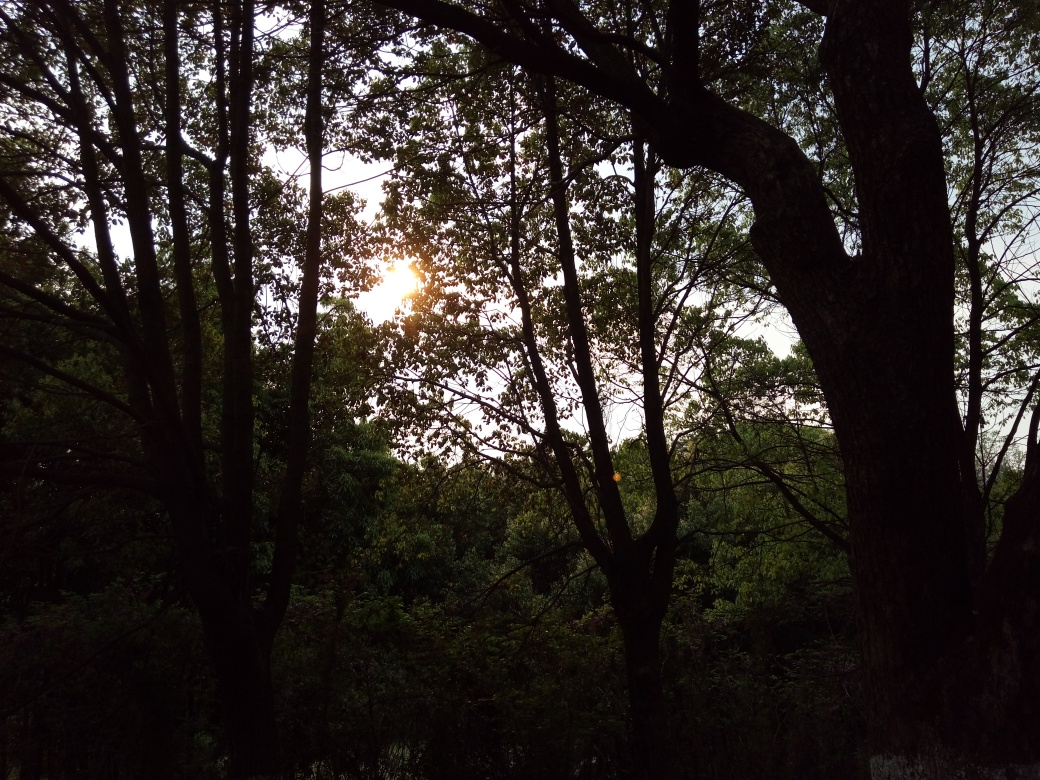What are the issues with the lighting conditions in this image?
 trees are mostly blacked out, no visible details, unclear outline of the sun, small glare 